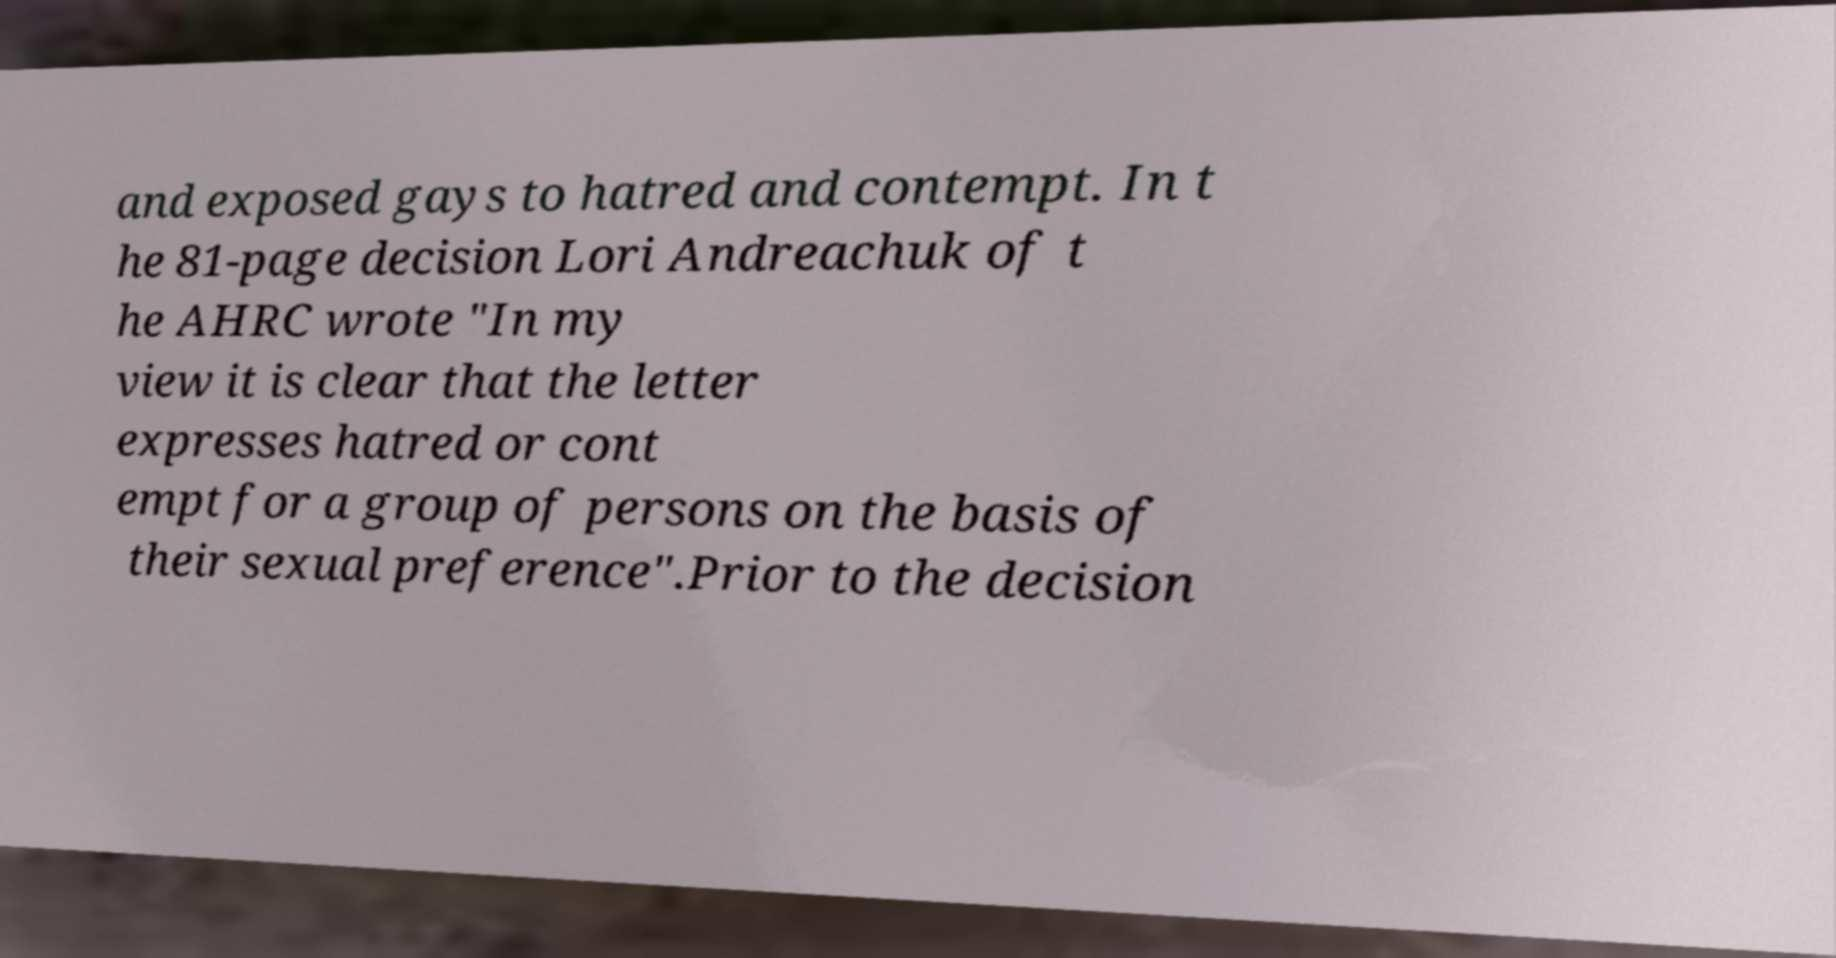I need the written content from this picture converted into text. Can you do that? and exposed gays to hatred and contempt. In t he 81-page decision Lori Andreachuk of t he AHRC wrote "In my view it is clear that the letter expresses hatred or cont empt for a group of persons on the basis of their sexual preference".Prior to the decision 